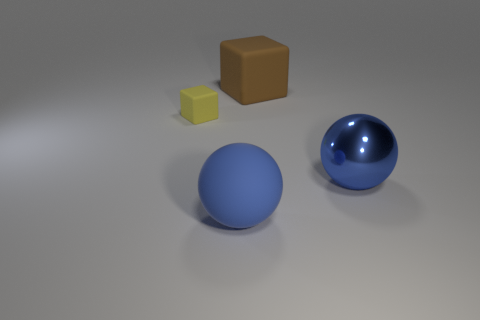Add 4 small cubes. How many objects exist? 8 Add 1 big matte spheres. How many big matte spheres exist? 2 Subtract 0 green balls. How many objects are left? 4 Subtract 2 balls. How many balls are left? 0 Subtract all gray spheres. Subtract all blue cylinders. How many spheres are left? 2 Subtract all purple cubes. How many brown balls are left? 0 Subtract all yellow cubes. Subtract all big rubber objects. How many objects are left? 1 Add 3 small rubber objects. How many small rubber objects are left? 4 